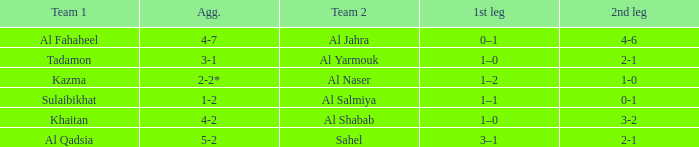Parse the full table. {'header': ['Team 1', 'Agg.', 'Team 2', '1st leg', '2nd leg'], 'rows': [['Al Fahaheel', '4-7', 'Al Jahra', '0–1', '4-6'], ['Tadamon', '3-1', 'Al Yarmouk', '1–0', '2-1'], ['Kazma', '2-2*', 'Al Naser', '1–2', '1-0'], ['Sulaibikhat', '1-2', 'Al Salmiya', '1–1', '0-1'], ['Khaitan', '4-2', 'Al Shabab', '1–0', '3-2'], ['Al Qadsia', '5-2', 'Sahel', '3–1', '2-1']]} What is the name of Team 2 with a 2nd leg of 4-6? Al Jahra. 